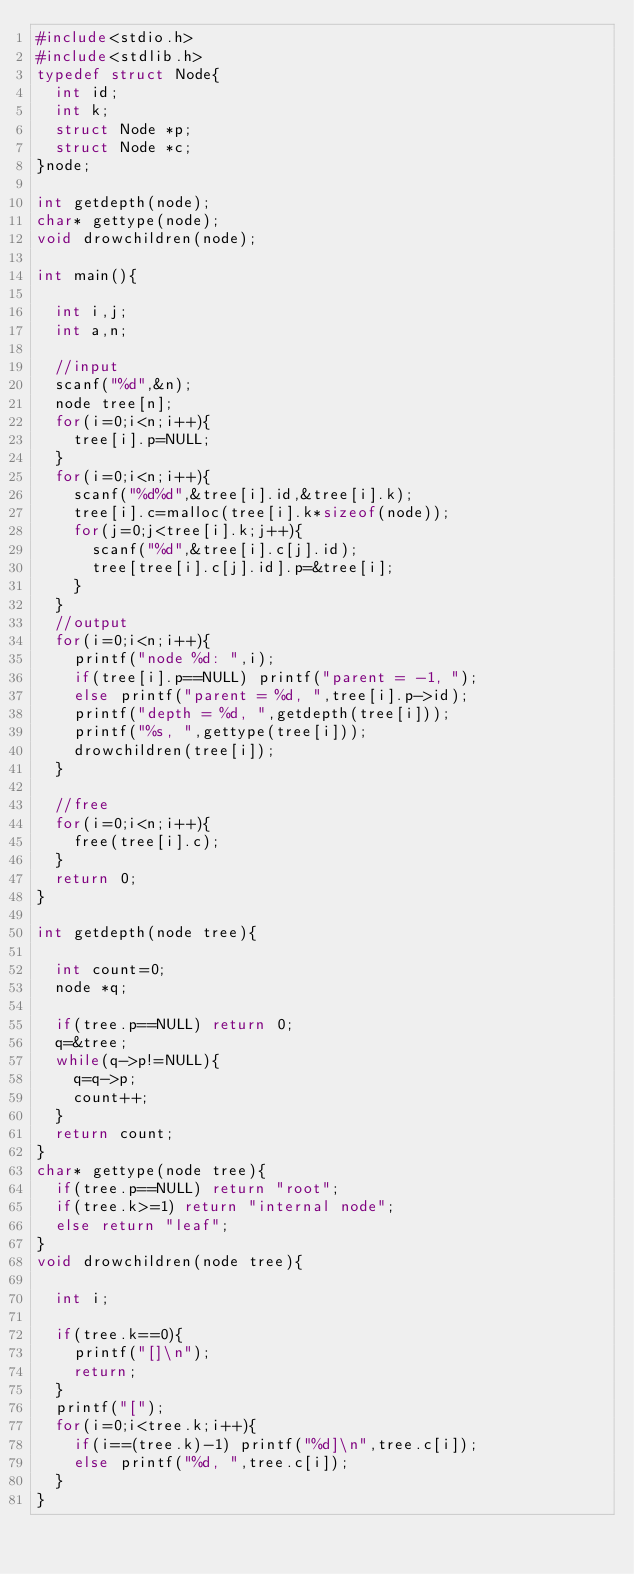Convert code to text. <code><loc_0><loc_0><loc_500><loc_500><_C_>#include<stdio.h>
#include<stdlib.h>
typedef struct Node{
  int id;
  int k;
  struct Node *p;
  struct Node *c;
}node;

int getdepth(node);
char* gettype(node);
void drowchildren(node);

int main(){

  int i,j;
  int a,n;

  //input
  scanf("%d",&n);
  node tree[n];
  for(i=0;i<n;i++){
    tree[i].p=NULL;
  }
  for(i=0;i<n;i++){
    scanf("%d%d",&tree[i].id,&tree[i].k);
    tree[i].c=malloc(tree[i].k*sizeof(node));
    for(j=0;j<tree[i].k;j++){
      scanf("%d",&tree[i].c[j].id);
      tree[tree[i].c[j].id].p=&tree[i];
    }
  }
  //output
  for(i=0;i<n;i++){
    printf("node %d: ",i);
    if(tree[i].p==NULL) printf("parent = -1, ");
    else printf("parent = %d, ",tree[i].p->id);
    printf("depth = %d, ",getdepth(tree[i]));
    printf("%s, ",gettype(tree[i]));
    drowchildren(tree[i]);
  }
  
  //free 
  for(i=0;i<n;i++){
    free(tree[i].c);
  }
  return 0;
}

int getdepth(node tree){

  int count=0;
  node *q;
  
  if(tree.p==NULL) return 0;
  q=&tree;
  while(q->p!=NULL){
    q=q->p;
    count++;
  }
  return count;
}
char* gettype(node tree){
  if(tree.p==NULL) return "root";
  if(tree.k>=1) return "internal node";
  else return "leaf";
}
void drowchildren(node tree){

  int i;

  if(tree.k==0){
    printf("[]\n");
    return;
  }
  printf("[");
  for(i=0;i<tree.k;i++){
    if(i==(tree.k)-1) printf("%d]\n",tree.c[i]);
    else printf("%d, ",tree.c[i]);
  }
}

</code> 